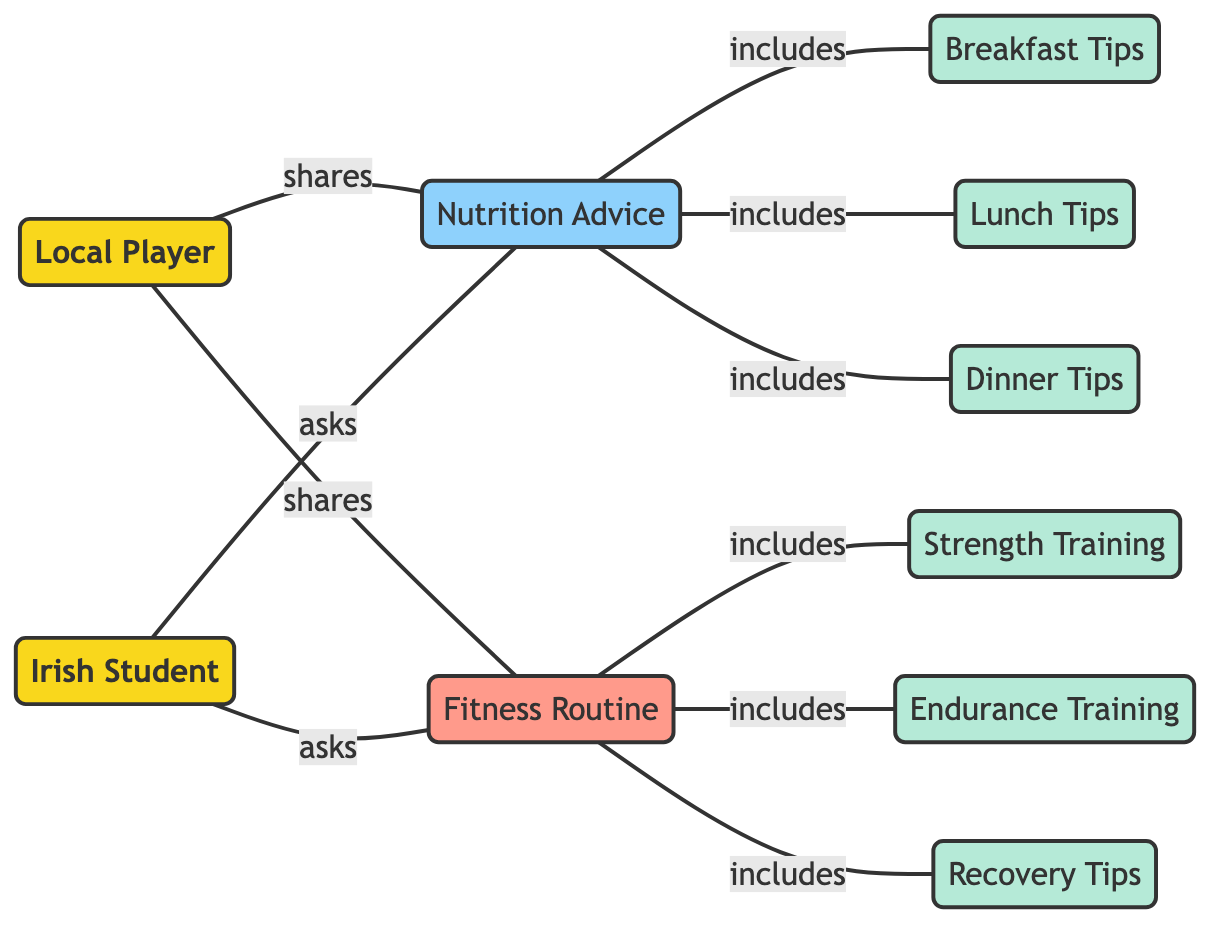What is the total number of nodes in the diagram? The diagram lists 10 distinct nodes, which include 2 players, 1 nutrition advice, 3 meal tips, 1 fitness routine, 3 types of training tips, making the total count 10.
Answer: 10 How many edges connect player A to other nodes? Player A has 2 outgoing edges; one connects to nutrition advice and the other to fitness routine. Therefore, there are 2 edges connected to player A.
Answer: 2 What type of advice does the Irish Student ask for? The Irish Student asks for both nutrition advice and fitness routine, as indicated by two incoming edges directed towards those nodes.
Answer: Nutrition Advice and Fitness Routine Which node includes breakfast tips? The node labeled "Nutrition Advice" includes breakfast tips, indicated by the edge labeled "includes" that connects them.
Answer: Nutrition Advice How many different types of training advice are included in the fitness routine? The fitness routine node includes three types of training advice: strength training, endurance training, and recovery tips. Therefore, the count is 3.
Answer: 3 Who shares nutrition advice? The local player shares nutrition advice, as indicated by the outgoing edge labeled "shares" that connects player A to the nutrition advice node.
Answer: Local Player What is the relationship between the Irish Student and nutrition advice? The relationship is that the Irish Student asks for nutrition advice, which is indicated by the incoming edge labeled "asks" from player B to the nutrition advice node.
Answer: asks Which nodes does nutrition advice include? Nutrition advice includes three nodes: breakfast tips, lunch tips, and dinner tips, as indicated by the three edges labeled "includes."
Answer: Breakfast Tips, Lunch Tips, Dinner Tips What are the two categories of advice included in the fitness routine? The categories of advice included in the fitness routine are strength training and endurance training, along with recovery tips, showing a distinction in types of training.
Answer: Strength Training, Endurance Training, Recovery Tips 